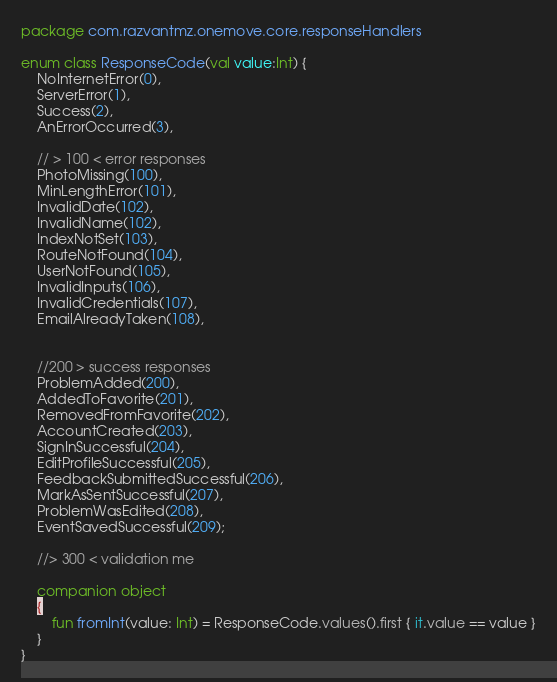<code> <loc_0><loc_0><loc_500><loc_500><_Kotlin_>package com.razvantmz.onemove.core.responseHandlers

enum class ResponseCode(val value:Int) {
    NoInternetError(0),
    ServerError(1),
    Success(2),
    AnErrorOccurred(3),

    // > 100 < error responses
    PhotoMissing(100),
    MinLengthError(101),
    InvalidDate(102),
    InvalidName(102),
    IndexNotSet(103),
    RouteNotFound(104),
    UserNotFound(105),
    InvalidInputs(106),
    InvalidCredentials(107),
    EmailAlreadyTaken(108),


    //200 > success responses
    ProblemAdded(200),
    AddedToFavorite(201),
    RemovedFromFavorite(202),
    AccountCreated(203),
    SignInSuccessful(204),
    EditProfileSuccessful(205),
    FeedbackSubmittedSuccessful(206),
    MarkAsSentSuccessful(207),
    ProblemWasEdited(208),
    EventSavedSuccessful(209);

    //> 300 < validation me

    companion object
    {
        fun fromInt(value: Int) = ResponseCode.values().first { it.value == value }
    }
}</code> 